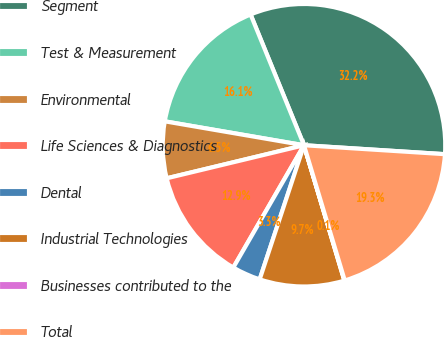<chart> <loc_0><loc_0><loc_500><loc_500><pie_chart><fcel>Segment<fcel>Test & Measurement<fcel>Environmental<fcel>Life Sciences & Diagnostics<fcel>Dental<fcel>Industrial Technologies<fcel>Businesses contributed to the<fcel>Total<nl><fcel>32.18%<fcel>16.12%<fcel>6.47%<fcel>12.9%<fcel>3.26%<fcel>9.69%<fcel>0.05%<fcel>19.33%<nl></chart> 